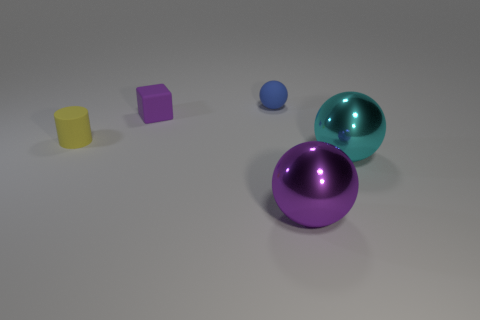There is a yellow thing that is behind the big metallic thing that is on the left side of the large cyan sphere; how many tiny purple objects are on the left side of it?
Provide a short and direct response. 0. What size is the rubber cylinder?
Your answer should be compact. Small. There is a blue thing that is the same size as the purple rubber thing; what material is it?
Offer a terse response. Rubber. What number of large cyan balls are on the left side of the purple metal thing?
Provide a succinct answer. 0. Does the purple thing that is to the left of the small blue rubber sphere have the same material as the big sphere in front of the big cyan thing?
Give a very brief answer. No. There is a metal thing on the left side of the big metal ball that is right of the shiny sphere left of the cyan metallic ball; what shape is it?
Make the answer very short. Sphere. What is the shape of the big cyan thing?
Keep it short and to the point. Sphere. There is another thing that is the same size as the purple metal object; what shape is it?
Provide a short and direct response. Sphere. How many other objects are there of the same color as the tiny sphere?
Provide a succinct answer. 0. Is the shape of the purple thing that is in front of the big cyan shiny object the same as the purple thing that is behind the large cyan metal sphere?
Offer a terse response. No. 